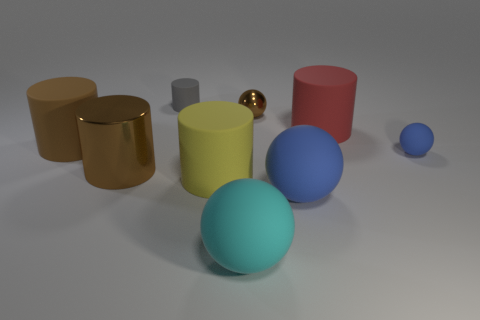Add 1 tiny cylinders. How many objects exist? 10 Subtract all small rubber balls. How many balls are left? 3 Subtract all gray cylinders. How many blue spheres are left? 2 Subtract 4 spheres. How many spheres are left? 0 Subtract all red cylinders. How many cylinders are left? 4 Subtract all balls. How many objects are left? 5 Subtract all yellow balls. Subtract all blue blocks. How many balls are left? 4 Subtract all green metal blocks. Subtract all tiny gray cylinders. How many objects are left? 8 Add 3 large brown matte cylinders. How many large brown matte cylinders are left? 4 Add 8 yellow things. How many yellow things exist? 9 